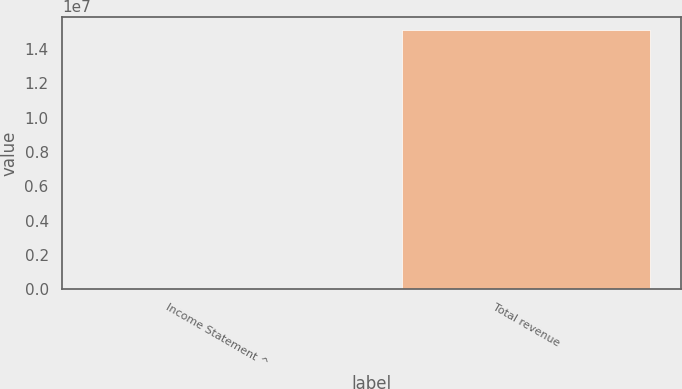<chart> <loc_0><loc_0><loc_500><loc_500><bar_chart><fcel>Income Statement ^<fcel>Total revenue<nl><fcel>2012<fcel>1.5119e+07<nl></chart> 